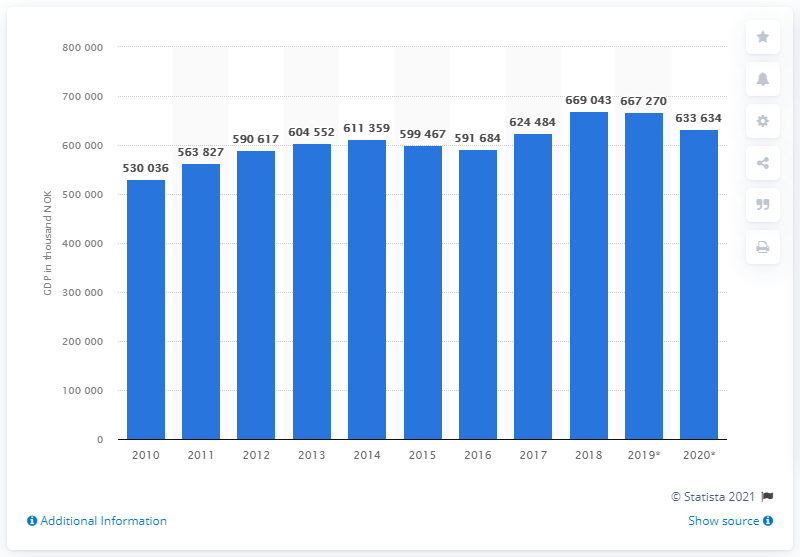Specify some key components in this picture. In 2020, the Gross Domestic Product (GDP) per capita in Norway was 63,363.4 US dollars. In 2010, Norway had a GDP per capita of approximately 530,000 US dollars. 